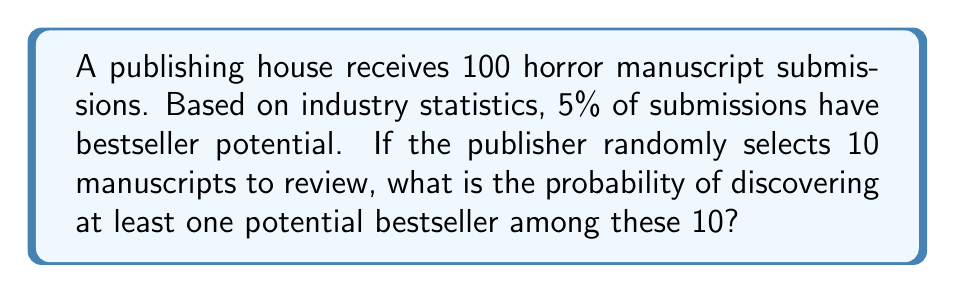Could you help me with this problem? Let's approach this step-by-step:

1) First, we need to identify the probability distribution. This scenario follows a binomial distribution, where we're looking for the probability of at least one success in a fixed number of trials.

2) Let's define our variables:
   $n = 10$ (number of manuscripts selected)
   $p = 0.05$ (probability of a manuscript being a potential bestseller)

3) We want to find the probability of at least one success. It's often easier to calculate this as the complement of the probability of no successes:

   $P(\text{at least one bestseller}) = 1 - P(\text{no bestsellers})$

4) The probability of no bestsellers in 10 selections is:

   $P(\text{no bestsellers}) = (1-p)^n = (0.95)^{10}$

5) Therefore, the probability of at least one bestseller is:

   $P(\text{at least one bestseller}) = 1 - (0.95)^{10}$

6) Let's calculate this:
   
   $1 - (0.95)^{10} = 1 - 0.5987 = 0.4013$

7) Converting to a percentage:

   $0.4013 \times 100\% = 40.13\%$
Answer: 40.13% 